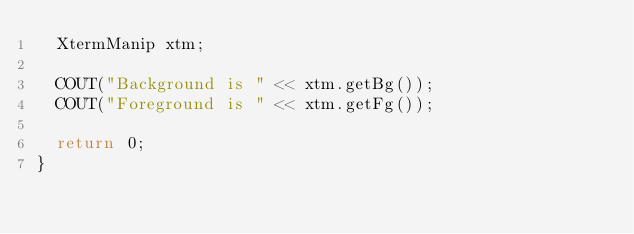<code> <loc_0><loc_0><loc_500><loc_500><_C++_>  XtermManip xtm;

  COUT("Background is " << xtm.getBg());
  COUT("Foreground is " << xtm.getFg());

  return 0;
}
</code> 